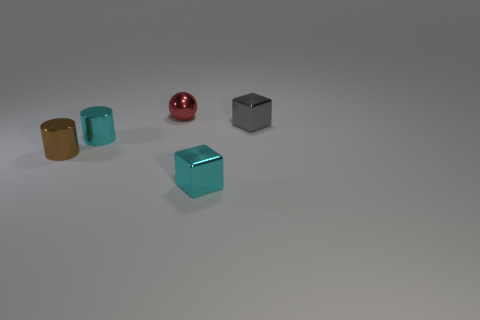Add 2 large blue spheres. How many objects exist? 7 Subtract all cubes. How many objects are left? 3 Subtract all large yellow cylinders. Subtract all tiny gray metallic things. How many objects are left? 4 Add 1 tiny gray objects. How many tiny gray objects are left? 2 Add 4 tiny red matte cubes. How many tiny red matte cubes exist? 4 Subtract 0 gray cylinders. How many objects are left? 5 